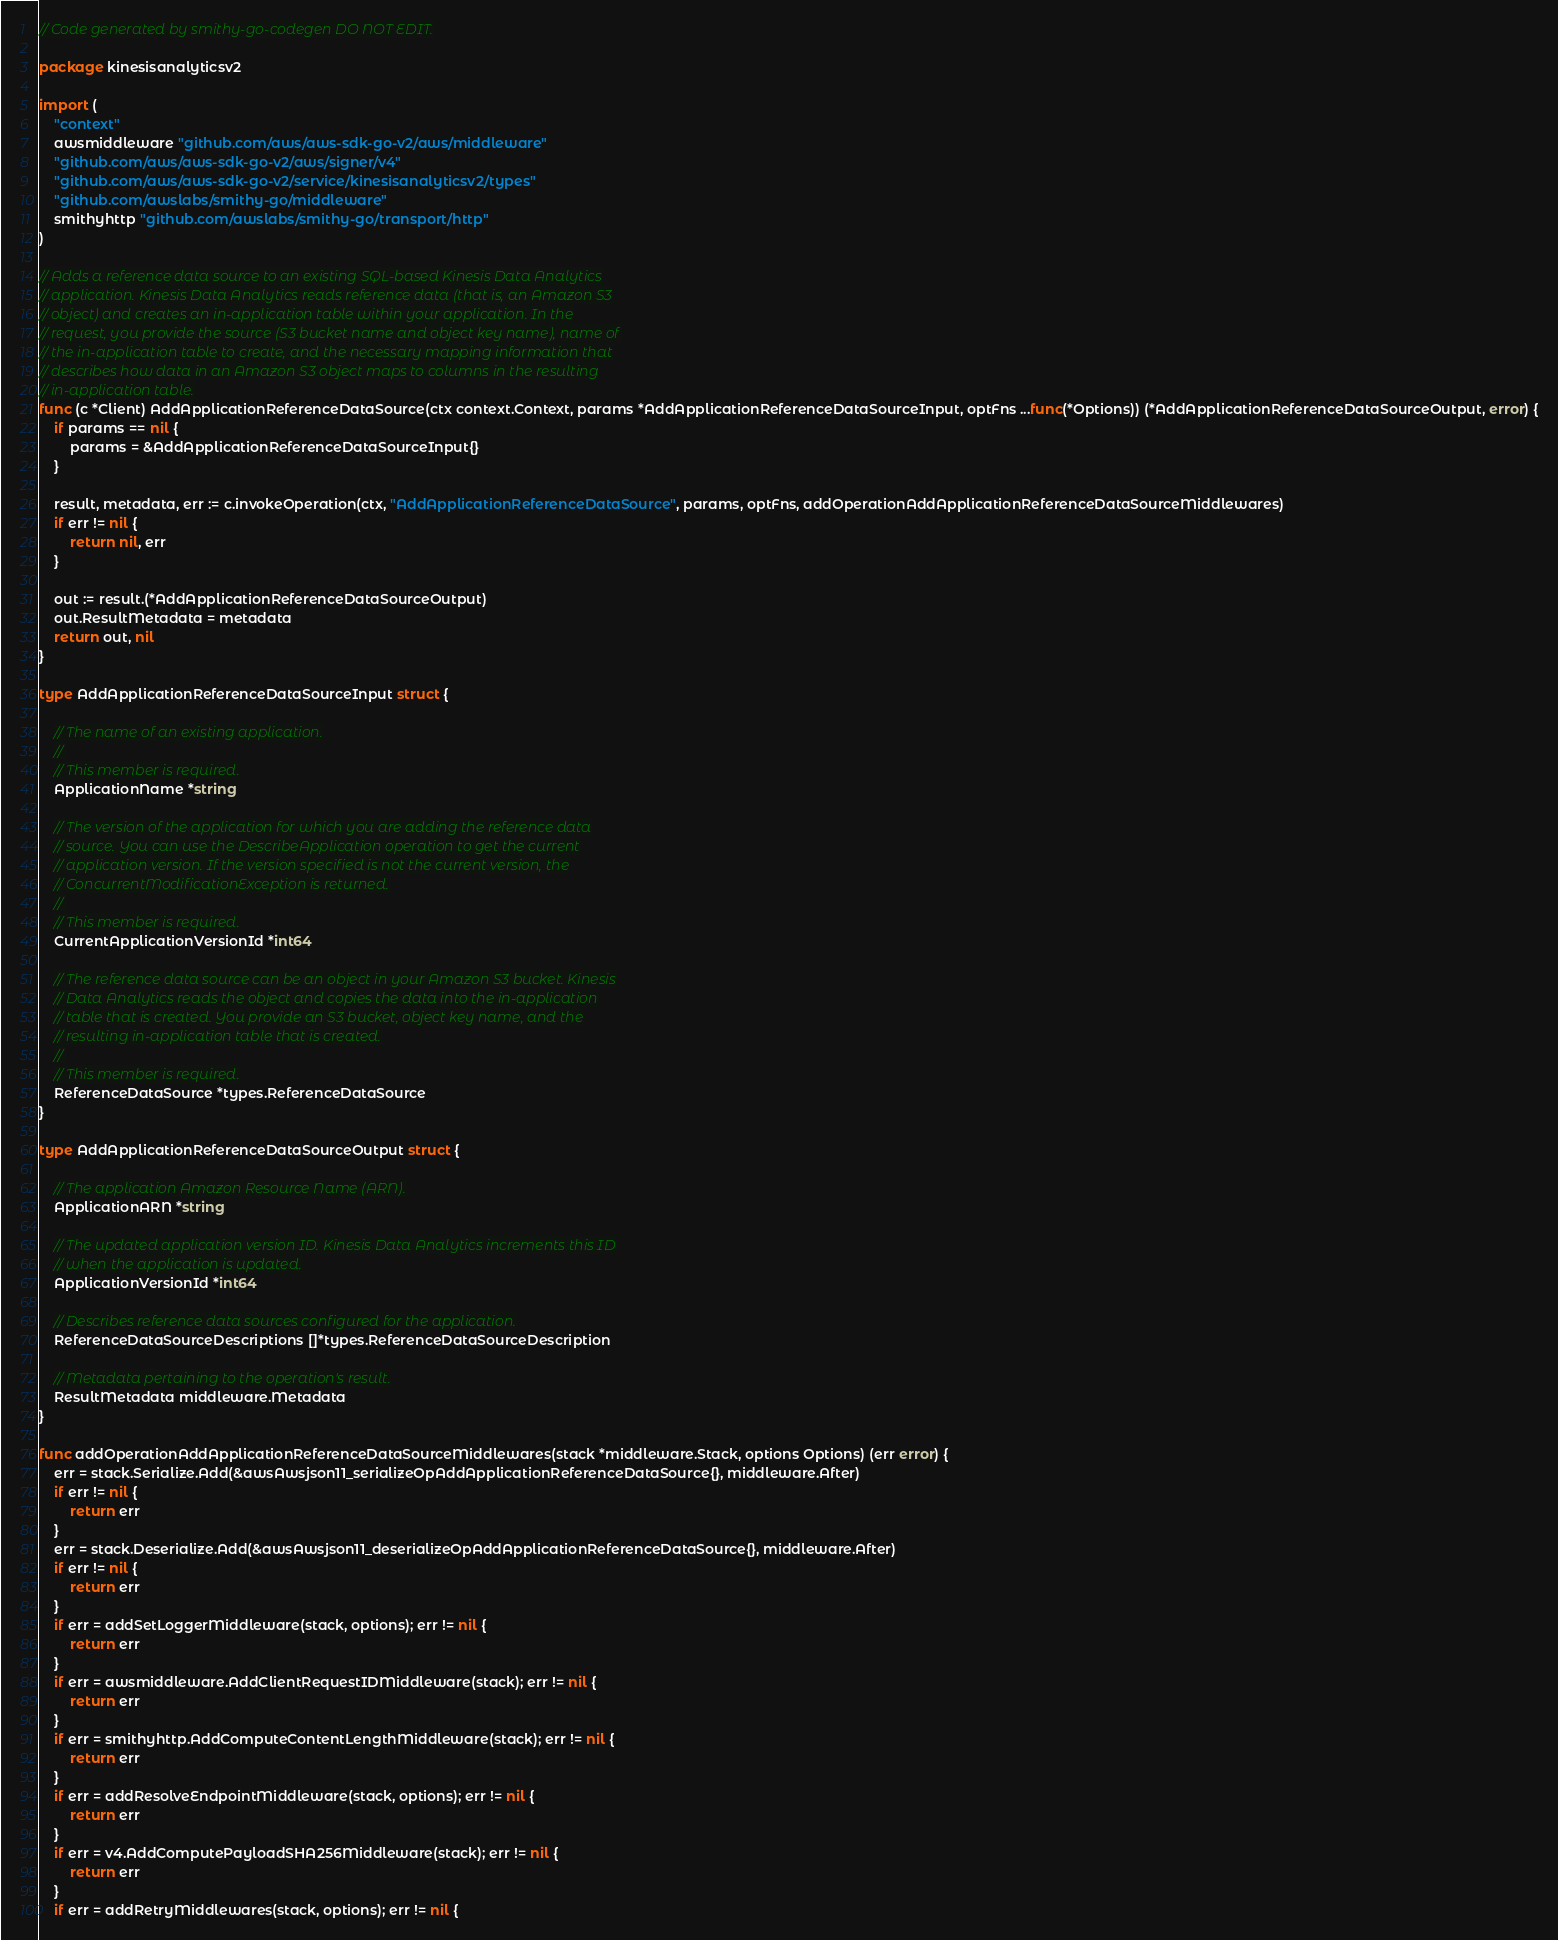<code> <loc_0><loc_0><loc_500><loc_500><_Go_>// Code generated by smithy-go-codegen DO NOT EDIT.

package kinesisanalyticsv2

import (
	"context"
	awsmiddleware "github.com/aws/aws-sdk-go-v2/aws/middleware"
	"github.com/aws/aws-sdk-go-v2/aws/signer/v4"
	"github.com/aws/aws-sdk-go-v2/service/kinesisanalyticsv2/types"
	"github.com/awslabs/smithy-go/middleware"
	smithyhttp "github.com/awslabs/smithy-go/transport/http"
)

// Adds a reference data source to an existing SQL-based Kinesis Data Analytics
// application. Kinesis Data Analytics reads reference data (that is, an Amazon S3
// object) and creates an in-application table within your application. In the
// request, you provide the source (S3 bucket name and object key name), name of
// the in-application table to create, and the necessary mapping information that
// describes how data in an Amazon S3 object maps to columns in the resulting
// in-application table.
func (c *Client) AddApplicationReferenceDataSource(ctx context.Context, params *AddApplicationReferenceDataSourceInput, optFns ...func(*Options)) (*AddApplicationReferenceDataSourceOutput, error) {
	if params == nil {
		params = &AddApplicationReferenceDataSourceInput{}
	}

	result, metadata, err := c.invokeOperation(ctx, "AddApplicationReferenceDataSource", params, optFns, addOperationAddApplicationReferenceDataSourceMiddlewares)
	if err != nil {
		return nil, err
	}

	out := result.(*AddApplicationReferenceDataSourceOutput)
	out.ResultMetadata = metadata
	return out, nil
}

type AddApplicationReferenceDataSourceInput struct {

	// The name of an existing application.
	//
	// This member is required.
	ApplicationName *string

	// The version of the application for which you are adding the reference data
	// source. You can use the DescribeApplication operation to get the current
	// application version. If the version specified is not the current version, the
	// ConcurrentModificationException is returned.
	//
	// This member is required.
	CurrentApplicationVersionId *int64

	// The reference data source can be an object in your Amazon S3 bucket. Kinesis
	// Data Analytics reads the object and copies the data into the in-application
	// table that is created. You provide an S3 bucket, object key name, and the
	// resulting in-application table that is created.
	//
	// This member is required.
	ReferenceDataSource *types.ReferenceDataSource
}

type AddApplicationReferenceDataSourceOutput struct {

	// The application Amazon Resource Name (ARN).
	ApplicationARN *string

	// The updated application version ID. Kinesis Data Analytics increments this ID
	// when the application is updated.
	ApplicationVersionId *int64

	// Describes reference data sources configured for the application.
	ReferenceDataSourceDescriptions []*types.ReferenceDataSourceDescription

	// Metadata pertaining to the operation's result.
	ResultMetadata middleware.Metadata
}

func addOperationAddApplicationReferenceDataSourceMiddlewares(stack *middleware.Stack, options Options) (err error) {
	err = stack.Serialize.Add(&awsAwsjson11_serializeOpAddApplicationReferenceDataSource{}, middleware.After)
	if err != nil {
		return err
	}
	err = stack.Deserialize.Add(&awsAwsjson11_deserializeOpAddApplicationReferenceDataSource{}, middleware.After)
	if err != nil {
		return err
	}
	if err = addSetLoggerMiddleware(stack, options); err != nil {
		return err
	}
	if err = awsmiddleware.AddClientRequestIDMiddleware(stack); err != nil {
		return err
	}
	if err = smithyhttp.AddComputeContentLengthMiddleware(stack); err != nil {
		return err
	}
	if err = addResolveEndpointMiddleware(stack, options); err != nil {
		return err
	}
	if err = v4.AddComputePayloadSHA256Middleware(stack); err != nil {
		return err
	}
	if err = addRetryMiddlewares(stack, options); err != nil {</code> 